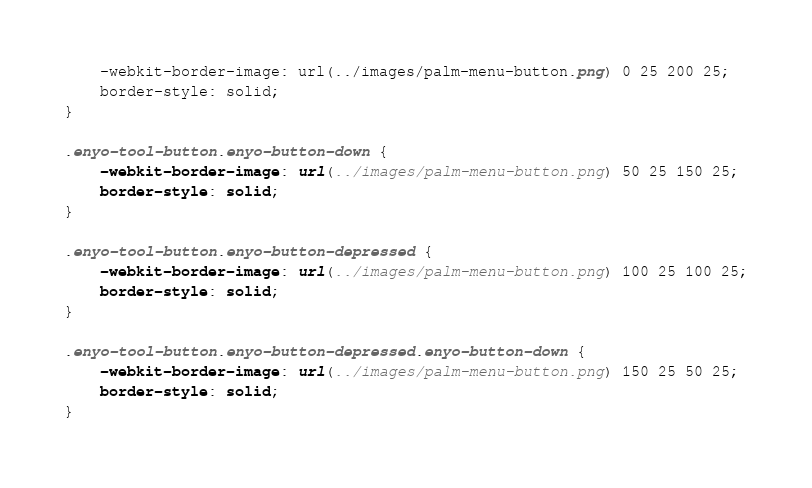Convert code to text. <code><loc_0><loc_0><loc_500><loc_500><_CSS_>	-webkit-border-image: url(../images/palm-menu-button.png) 0 25 200 25;
	border-style: solid;
}

.enyo-tool-button.enyo-button-down {
	-webkit-border-image: url(../images/palm-menu-button.png) 50 25 150 25;
	border-style: solid;
}

.enyo-tool-button.enyo-button-depressed {
	-webkit-border-image: url(../images/palm-menu-button.png) 100 25 100 25;
	border-style: solid;
}

.enyo-tool-button.enyo-button-depressed.enyo-button-down {
	-webkit-border-image: url(../images/palm-menu-button.png) 150 25 50 25;
	border-style: solid;
}
</code> 